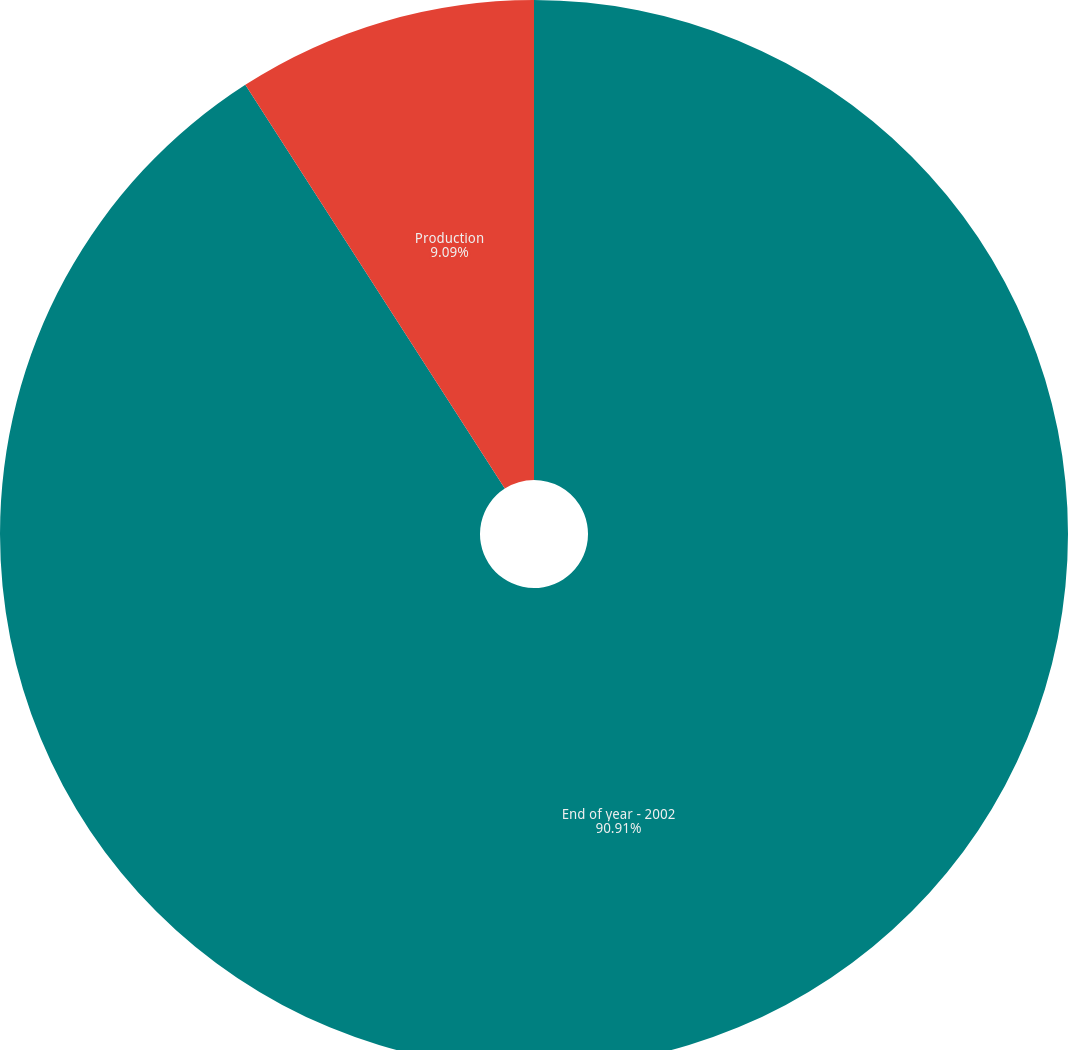Convert chart. <chart><loc_0><loc_0><loc_500><loc_500><pie_chart><fcel>End of year - 2002<fcel>Production<nl><fcel>90.91%<fcel>9.09%<nl></chart> 